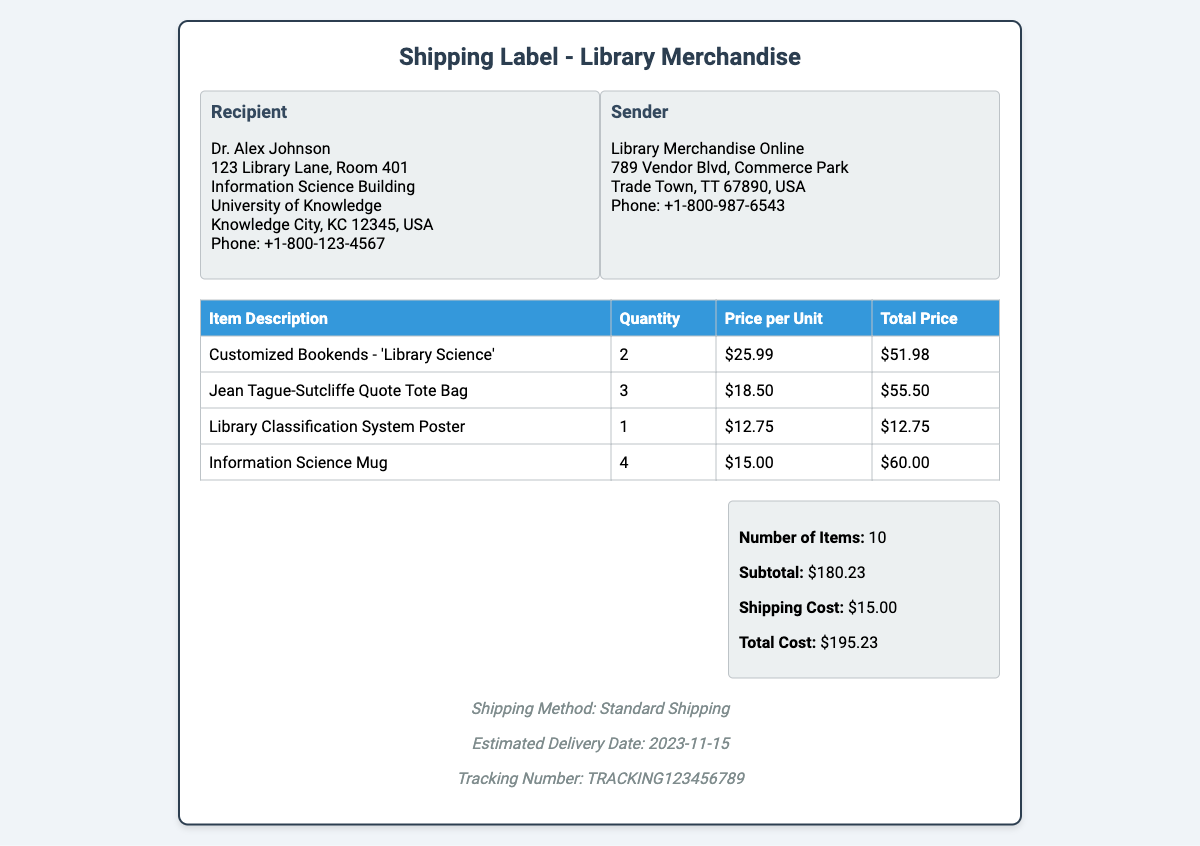What is the total cost of the order? The total cost is listed as the sum of the subtotal and shipping cost, which is $180.23 + $15.00.
Answer: $195.23 Who is the recipient of the shipping label? The recipient's information is provided at the top of the document, identifying the person to receive the order.
Answer: Dr. Alex Johnson How many items are there in total? The document specifies the number of items purchased in the order.
Answer: 10 What is the price of one 'Jean Tague-Sutcliffe Quote Tote Bag'? The price listed for each unit of that particular item is stated in the order details.
Answer: $18.50 What is the estimated delivery date? The document includes a section that specifies when the delivery is expected to arrive.
Answer: 2023-11-15 What is the shipping method used for the delivery? The shipping method is indicated in the delivery information of the label.
Answer: Standard Shipping What is the subtotal of the order? The subtotal is calculated from the total prices of all items before adding shipping costs.
Answer: $180.23 How many 'Information Science Mugs' were ordered? The document lists the quantity of each item ordered, including this specific mug.
Answer: 4 What is the tracking number for the shipment? The tracking number is included in the delivery information section of the shipping label.
Answer: TRACKING123456789 